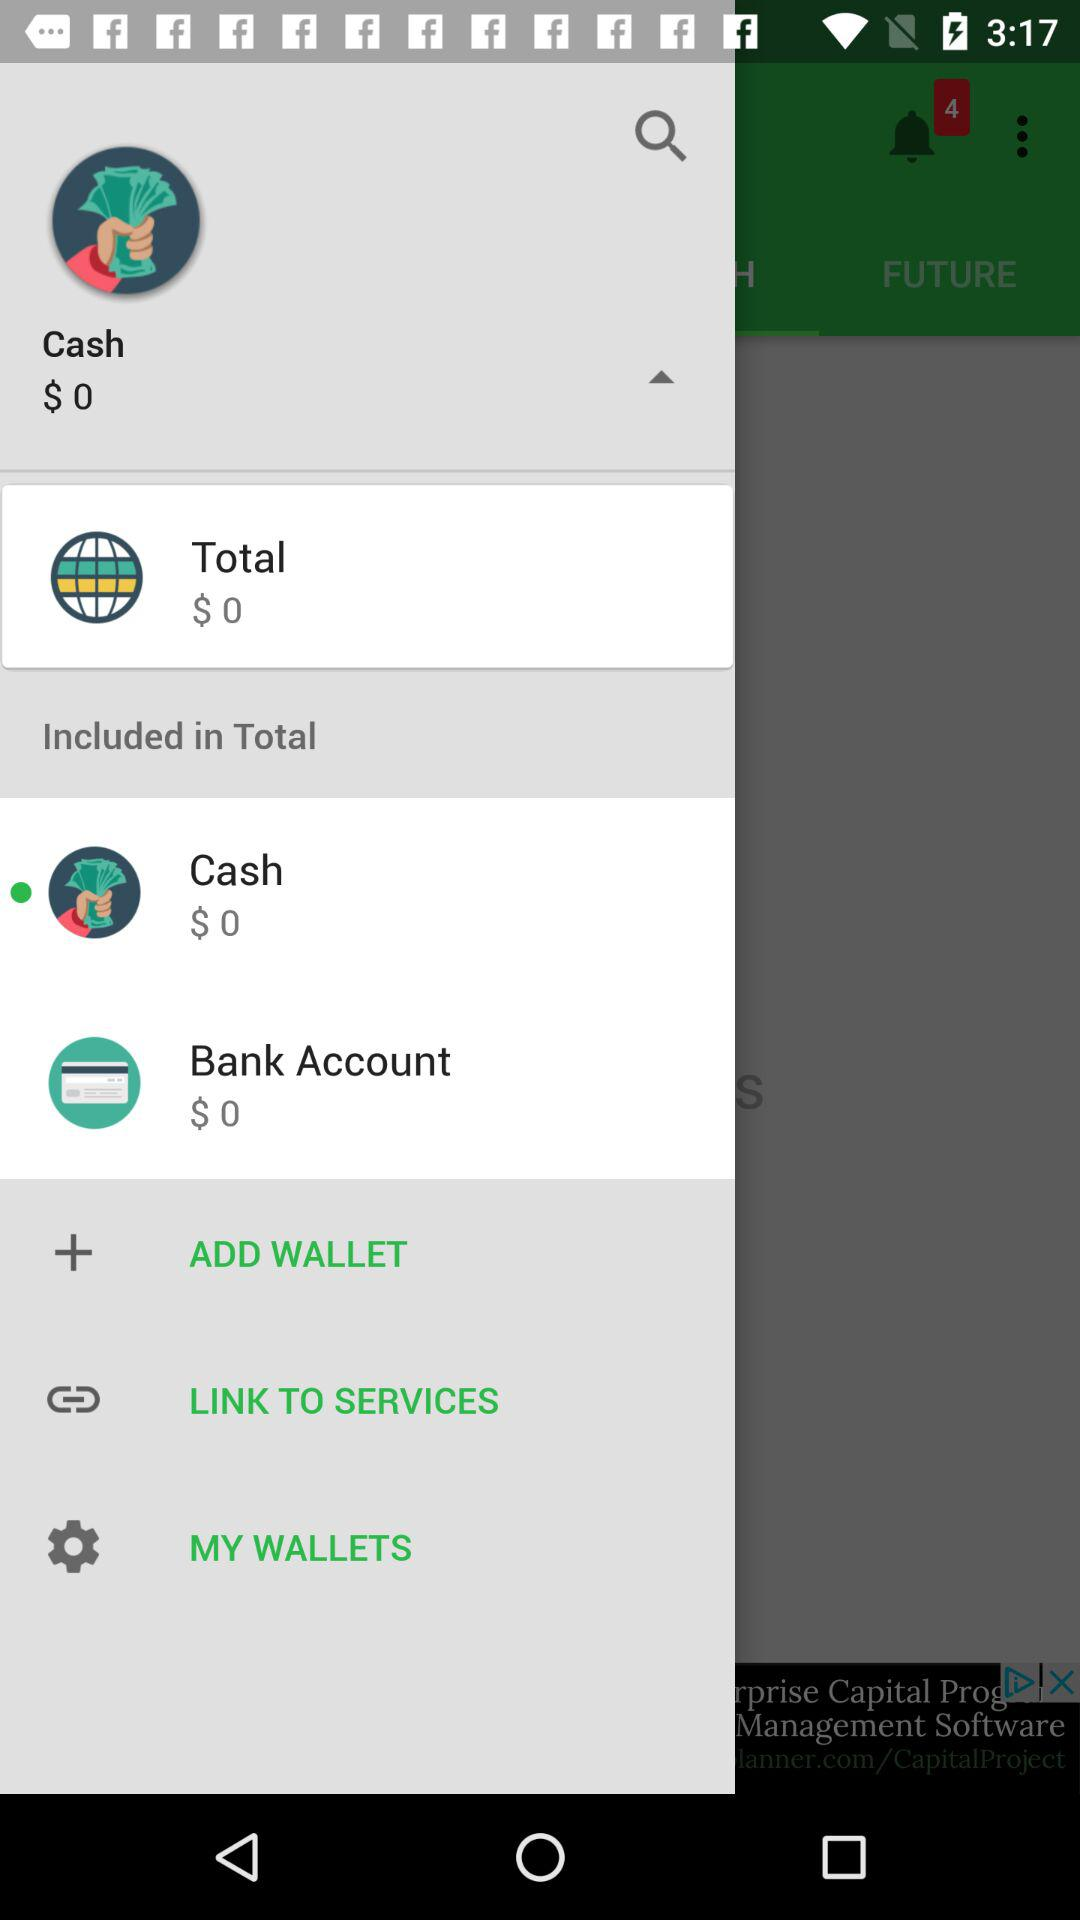How many dollars are there in the bank account? There are 0 dollars in the bank account. 